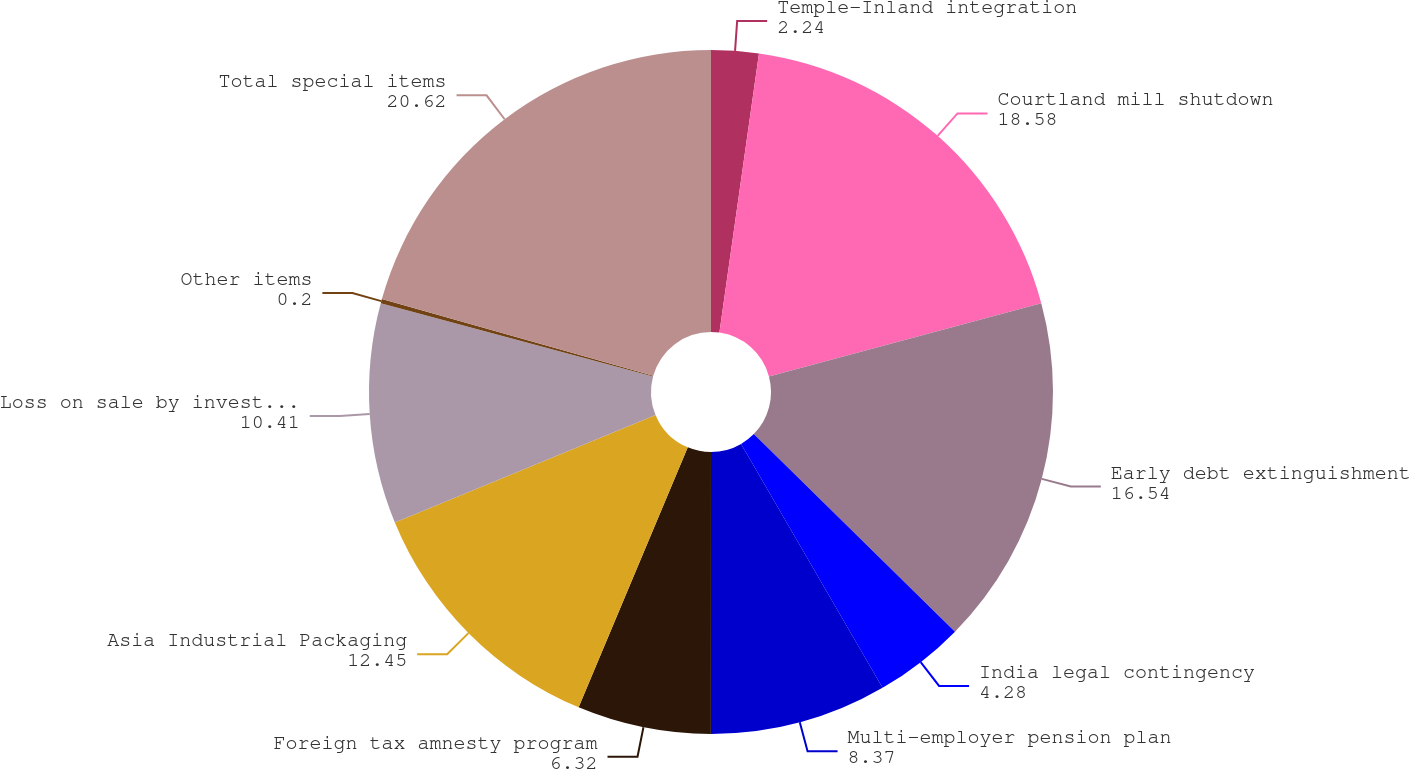Convert chart to OTSL. <chart><loc_0><loc_0><loc_500><loc_500><pie_chart><fcel>Temple-Inland integration<fcel>Courtland mill shutdown<fcel>Early debt extinguishment<fcel>India legal contingency<fcel>Multi-employer pension plan<fcel>Foreign tax amnesty program<fcel>Asia Industrial Packaging<fcel>Loss on sale by investee and<fcel>Other items<fcel>Total special items<nl><fcel>2.24%<fcel>18.58%<fcel>16.54%<fcel>4.28%<fcel>8.37%<fcel>6.32%<fcel>12.45%<fcel>10.41%<fcel>0.2%<fcel>20.62%<nl></chart> 